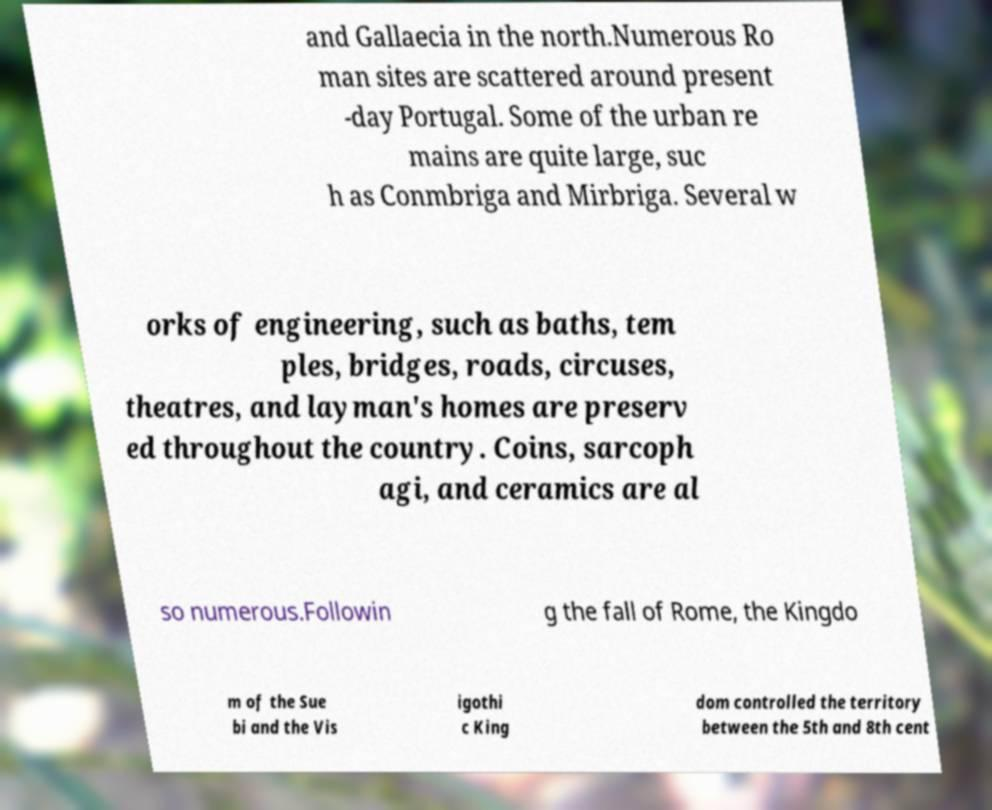Could you assist in decoding the text presented in this image and type it out clearly? and Gallaecia in the north.Numerous Ro man sites are scattered around present -day Portugal. Some of the urban re mains are quite large, suc h as Conmbriga and Mirbriga. Several w orks of engineering, such as baths, tem ples, bridges, roads, circuses, theatres, and layman's homes are preserv ed throughout the country. Coins, sarcoph agi, and ceramics are al so numerous.Followin g the fall of Rome, the Kingdo m of the Sue bi and the Vis igothi c King dom controlled the territory between the 5th and 8th cent 